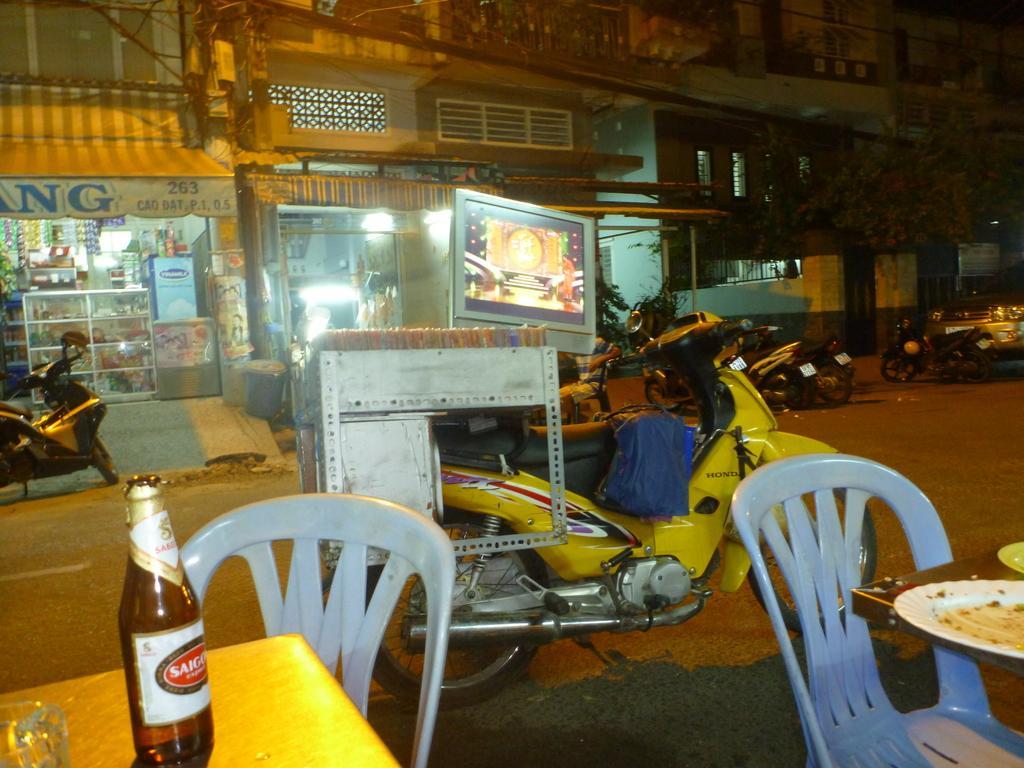Could you give a brief overview of what you see in this image? In this picture we can see buildings and stores. Here we can see a bike in yellow colour and there is a bag on it. we can see chairs and tables and on the table we can see a plate of food, a bottle and glass. This is a road. We can see few bikes parked in front of a building and stores. 